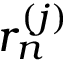Convert formula to latex. <formula><loc_0><loc_0><loc_500><loc_500>r _ { n } ^ { ( j ) }</formula> 